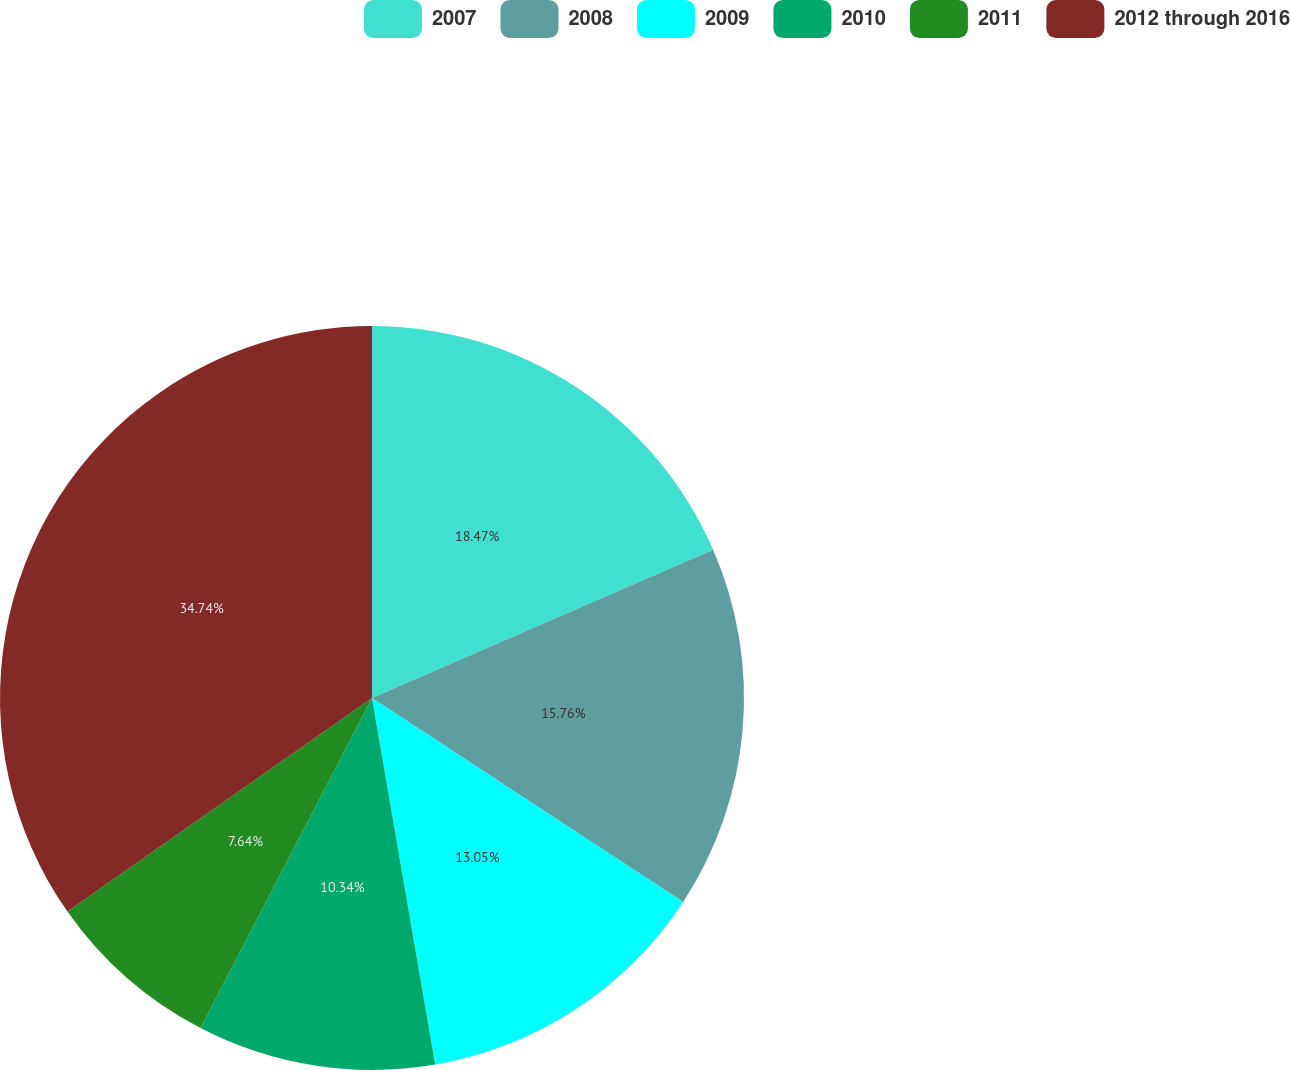Convert chart. <chart><loc_0><loc_0><loc_500><loc_500><pie_chart><fcel>2007<fcel>2008<fcel>2009<fcel>2010<fcel>2011<fcel>2012 through 2016<nl><fcel>18.47%<fcel>15.76%<fcel>13.05%<fcel>10.34%<fcel>7.64%<fcel>34.73%<nl></chart> 